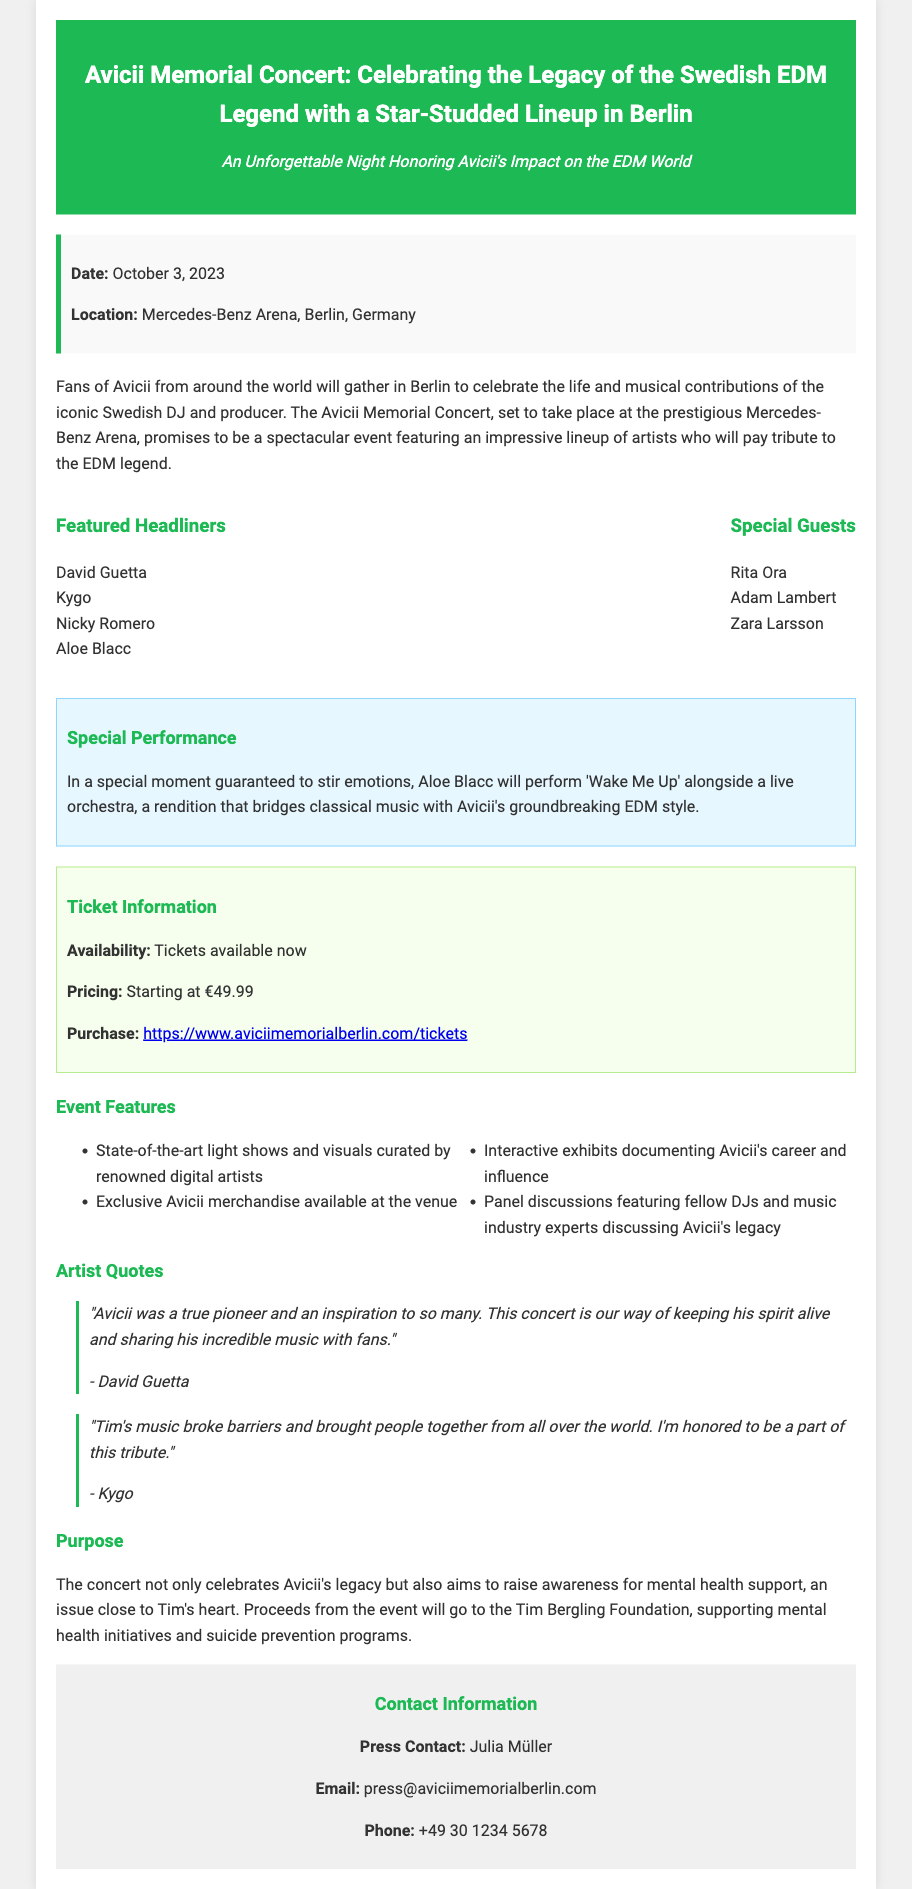What is the date of the concert? The date of the concert is specified in the document.
Answer: October 3, 2023 Where is the concert taking place? The location of the concert is mentioned in the event details.
Answer: Mercedes-Benz Arena, Berlin, Germany Who is performing 'Wake Me Up' with a live orchestra? The document highlights a special performance involving a specific artist.
Answer: Aloe Blacc What is the starting ticket price? The pricing information for tickets is provided in the ticket section.
Answer: €49.99 Which foundation will receive the proceeds from the event? The purpose section of the document states the organization benefiting from the concert's profits.
Answer: Tim Bergling Foundation How many featured headliners are listed? This requires counting the headliners mentioned in the lineup section.
Answer: Four What type of performances can attendees expect? The document describes event features that indicate the nature of the performances.
Answer: State-of-the-art light shows and visuals Who is the press contact for the event? The contact information section gives the name of the press contact.
Answer: Julia Müller 